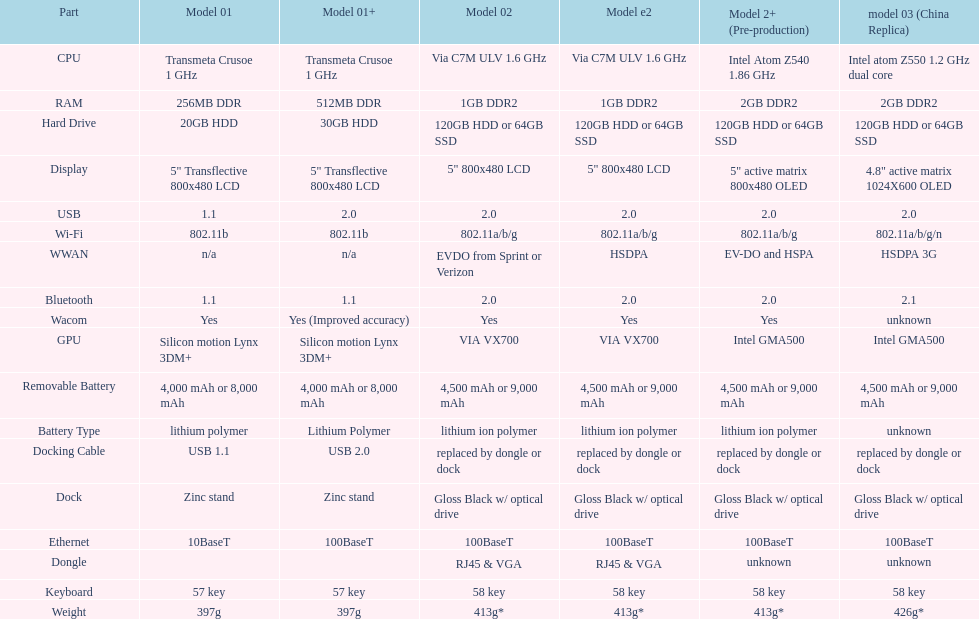What component comes after bluetooth? Wacom. 